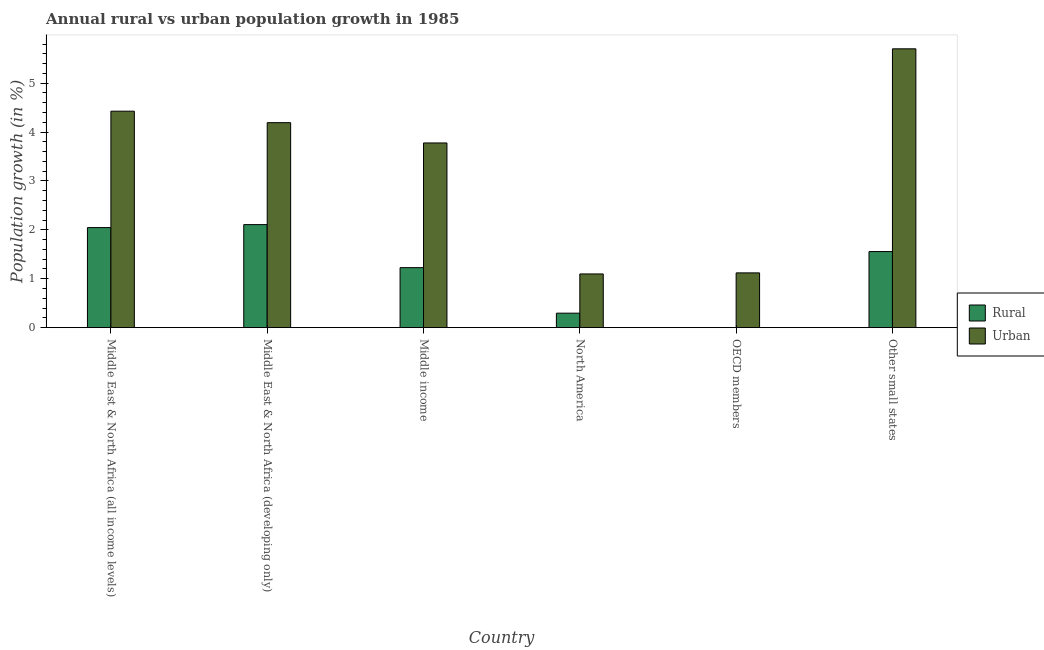What is the urban population growth in OECD members?
Your answer should be compact. 1.12. Across all countries, what is the maximum urban population growth?
Offer a very short reply. 5.7. Across all countries, what is the minimum urban population growth?
Provide a succinct answer. 1.1. In which country was the rural population growth maximum?
Make the answer very short. Middle East & North Africa (developing only). What is the total urban population growth in the graph?
Your answer should be compact. 20.32. What is the difference between the urban population growth in Middle income and that in North America?
Give a very brief answer. 2.68. What is the difference between the rural population growth in Middle East & North Africa (developing only) and the urban population growth in Middle East & North Africa (all income levels)?
Provide a short and direct response. -2.32. What is the average rural population growth per country?
Your answer should be very brief. 1.21. What is the difference between the urban population growth and rural population growth in Middle East & North Africa (all income levels)?
Offer a terse response. 2.38. In how many countries, is the rural population growth greater than 0.4 %?
Your answer should be compact. 4. What is the ratio of the rural population growth in Middle East & North Africa (developing only) to that in Other small states?
Provide a succinct answer. 1.35. Is the difference between the rural population growth in Middle East & North Africa (all income levels) and Middle East & North Africa (developing only) greater than the difference between the urban population growth in Middle East & North Africa (all income levels) and Middle East & North Africa (developing only)?
Your answer should be very brief. No. What is the difference between the highest and the second highest rural population growth?
Your response must be concise. 0.06. What is the difference between the highest and the lowest rural population growth?
Ensure brevity in your answer.  2.11. Are all the bars in the graph horizontal?
Offer a terse response. No. How many countries are there in the graph?
Give a very brief answer. 6. What is the difference between two consecutive major ticks on the Y-axis?
Provide a succinct answer. 1. Does the graph contain any zero values?
Your response must be concise. Yes. How many legend labels are there?
Your answer should be compact. 2. What is the title of the graph?
Keep it short and to the point. Annual rural vs urban population growth in 1985. What is the label or title of the Y-axis?
Make the answer very short. Population growth (in %). What is the Population growth (in %) in Rural in Middle East & North Africa (all income levels)?
Provide a short and direct response. 2.05. What is the Population growth (in %) of Urban  in Middle East & North Africa (all income levels)?
Provide a succinct answer. 4.43. What is the Population growth (in %) in Rural in Middle East & North Africa (developing only)?
Provide a succinct answer. 2.11. What is the Population growth (in %) in Urban  in Middle East & North Africa (developing only)?
Ensure brevity in your answer.  4.19. What is the Population growth (in %) in Rural in Middle income?
Provide a succinct answer. 1.23. What is the Population growth (in %) in Urban  in Middle income?
Offer a very short reply. 3.78. What is the Population growth (in %) of Rural in North America?
Your response must be concise. 0.3. What is the Population growth (in %) of Urban  in North America?
Your response must be concise. 1.1. What is the Population growth (in %) in Rural in OECD members?
Make the answer very short. 0. What is the Population growth (in %) in Urban  in OECD members?
Ensure brevity in your answer.  1.12. What is the Population growth (in %) of Rural in Other small states?
Your answer should be compact. 1.56. What is the Population growth (in %) in Urban  in Other small states?
Your answer should be compact. 5.7. Across all countries, what is the maximum Population growth (in %) in Rural?
Your answer should be very brief. 2.11. Across all countries, what is the maximum Population growth (in %) in Urban ?
Offer a very short reply. 5.7. Across all countries, what is the minimum Population growth (in %) in Urban ?
Your answer should be very brief. 1.1. What is the total Population growth (in %) of Rural in the graph?
Provide a short and direct response. 7.24. What is the total Population growth (in %) of Urban  in the graph?
Give a very brief answer. 20.32. What is the difference between the Population growth (in %) in Rural in Middle East & North Africa (all income levels) and that in Middle East & North Africa (developing only)?
Your response must be concise. -0.06. What is the difference between the Population growth (in %) in Urban  in Middle East & North Africa (all income levels) and that in Middle East & North Africa (developing only)?
Offer a very short reply. 0.23. What is the difference between the Population growth (in %) in Rural in Middle East & North Africa (all income levels) and that in Middle income?
Give a very brief answer. 0.82. What is the difference between the Population growth (in %) in Urban  in Middle East & North Africa (all income levels) and that in Middle income?
Provide a succinct answer. 0.65. What is the difference between the Population growth (in %) of Rural in Middle East & North Africa (all income levels) and that in North America?
Give a very brief answer. 1.75. What is the difference between the Population growth (in %) of Urban  in Middle East & North Africa (all income levels) and that in North America?
Your response must be concise. 3.33. What is the difference between the Population growth (in %) of Urban  in Middle East & North Africa (all income levels) and that in OECD members?
Ensure brevity in your answer.  3.31. What is the difference between the Population growth (in %) of Rural in Middle East & North Africa (all income levels) and that in Other small states?
Make the answer very short. 0.49. What is the difference between the Population growth (in %) of Urban  in Middle East & North Africa (all income levels) and that in Other small states?
Make the answer very short. -1.28. What is the difference between the Population growth (in %) of Rural in Middle East & North Africa (developing only) and that in Middle income?
Keep it short and to the point. 0.88. What is the difference between the Population growth (in %) of Urban  in Middle East & North Africa (developing only) and that in Middle income?
Provide a succinct answer. 0.41. What is the difference between the Population growth (in %) in Rural in Middle East & North Africa (developing only) and that in North America?
Make the answer very short. 1.81. What is the difference between the Population growth (in %) in Urban  in Middle East & North Africa (developing only) and that in North America?
Offer a terse response. 3.09. What is the difference between the Population growth (in %) of Urban  in Middle East & North Africa (developing only) and that in OECD members?
Keep it short and to the point. 3.07. What is the difference between the Population growth (in %) in Rural in Middle East & North Africa (developing only) and that in Other small states?
Give a very brief answer. 0.55. What is the difference between the Population growth (in %) of Urban  in Middle East & North Africa (developing only) and that in Other small states?
Your answer should be compact. -1.51. What is the difference between the Population growth (in %) of Rural in Middle income and that in North America?
Keep it short and to the point. 0.93. What is the difference between the Population growth (in %) in Urban  in Middle income and that in North America?
Your response must be concise. 2.68. What is the difference between the Population growth (in %) of Urban  in Middle income and that in OECD members?
Ensure brevity in your answer.  2.66. What is the difference between the Population growth (in %) in Rural in Middle income and that in Other small states?
Keep it short and to the point. -0.33. What is the difference between the Population growth (in %) in Urban  in Middle income and that in Other small states?
Your answer should be very brief. -1.93. What is the difference between the Population growth (in %) of Urban  in North America and that in OECD members?
Ensure brevity in your answer.  -0.02. What is the difference between the Population growth (in %) of Rural in North America and that in Other small states?
Ensure brevity in your answer.  -1.26. What is the difference between the Population growth (in %) in Urban  in North America and that in Other small states?
Your response must be concise. -4.6. What is the difference between the Population growth (in %) of Urban  in OECD members and that in Other small states?
Your answer should be compact. -4.58. What is the difference between the Population growth (in %) of Rural in Middle East & North Africa (all income levels) and the Population growth (in %) of Urban  in Middle East & North Africa (developing only)?
Make the answer very short. -2.15. What is the difference between the Population growth (in %) in Rural in Middle East & North Africa (all income levels) and the Population growth (in %) in Urban  in Middle income?
Ensure brevity in your answer.  -1.73. What is the difference between the Population growth (in %) in Rural in Middle East & North Africa (all income levels) and the Population growth (in %) in Urban  in North America?
Offer a terse response. 0.95. What is the difference between the Population growth (in %) in Rural in Middle East & North Africa (all income levels) and the Population growth (in %) in Urban  in OECD members?
Ensure brevity in your answer.  0.93. What is the difference between the Population growth (in %) of Rural in Middle East & North Africa (all income levels) and the Population growth (in %) of Urban  in Other small states?
Provide a succinct answer. -3.66. What is the difference between the Population growth (in %) in Rural in Middle East & North Africa (developing only) and the Population growth (in %) in Urban  in Middle income?
Make the answer very short. -1.67. What is the difference between the Population growth (in %) in Rural in Middle East & North Africa (developing only) and the Population growth (in %) in Urban  in North America?
Offer a very short reply. 1.01. What is the difference between the Population growth (in %) of Rural in Middle East & North Africa (developing only) and the Population growth (in %) of Urban  in Other small states?
Provide a succinct answer. -3.6. What is the difference between the Population growth (in %) of Rural in Middle income and the Population growth (in %) of Urban  in North America?
Your response must be concise. 0.13. What is the difference between the Population growth (in %) in Rural in Middle income and the Population growth (in %) in Urban  in OECD members?
Offer a very short reply. 0.11. What is the difference between the Population growth (in %) in Rural in Middle income and the Population growth (in %) in Urban  in Other small states?
Keep it short and to the point. -4.48. What is the difference between the Population growth (in %) in Rural in North America and the Population growth (in %) in Urban  in OECD members?
Keep it short and to the point. -0.82. What is the difference between the Population growth (in %) in Rural in North America and the Population growth (in %) in Urban  in Other small states?
Provide a succinct answer. -5.41. What is the average Population growth (in %) of Rural per country?
Your answer should be very brief. 1.21. What is the average Population growth (in %) in Urban  per country?
Your response must be concise. 3.39. What is the difference between the Population growth (in %) in Rural and Population growth (in %) in Urban  in Middle East & North Africa (all income levels)?
Offer a terse response. -2.38. What is the difference between the Population growth (in %) in Rural and Population growth (in %) in Urban  in Middle East & North Africa (developing only)?
Your response must be concise. -2.09. What is the difference between the Population growth (in %) of Rural and Population growth (in %) of Urban  in Middle income?
Your response must be concise. -2.55. What is the difference between the Population growth (in %) of Rural and Population growth (in %) of Urban  in North America?
Provide a succinct answer. -0.8. What is the difference between the Population growth (in %) in Rural and Population growth (in %) in Urban  in Other small states?
Provide a short and direct response. -4.15. What is the ratio of the Population growth (in %) of Rural in Middle East & North Africa (all income levels) to that in Middle East & North Africa (developing only)?
Keep it short and to the point. 0.97. What is the ratio of the Population growth (in %) in Urban  in Middle East & North Africa (all income levels) to that in Middle East & North Africa (developing only)?
Your response must be concise. 1.06. What is the ratio of the Population growth (in %) in Rural in Middle East & North Africa (all income levels) to that in Middle income?
Your answer should be very brief. 1.67. What is the ratio of the Population growth (in %) in Urban  in Middle East & North Africa (all income levels) to that in Middle income?
Offer a very short reply. 1.17. What is the ratio of the Population growth (in %) in Rural in Middle East & North Africa (all income levels) to that in North America?
Keep it short and to the point. 6.9. What is the ratio of the Population growth (in %) in Urban  in Middle East & North Africa (all income levels) to that in North America?
Give a very brief answer. 4.03. What is the ratio of the Population growth (in %) in Urban  in Middle East & North Africa (all income levels) to that in OECD members?
Offer a terse response. 3.95. What is the ratio of the Population growth (in %) in Rural in Middle East & North Africa (all income levels) to that in Other small states?
Offer a very short reply. 1.32. What is the ratio of the Population growth (in %) of Urban  in Middle East & North Africa (all income levels) to that in Other small states?
Your answer should be compact. 0.78. What is the ratio of the Population growth (in %) in Rural in Middle East & North Africa (developing only) to that in Middle income?
Provide a short and direct response. 1.72. What is the ratio of the Population growth (in %) in Urban  in Middle East & North Africa (developing only) to that in Middle income?
Offer a terse response. 1.11. What is the ratio of the Population growth (in %) in Rural in Middle East & North Africa (developing only) to that in North America?
Your answer should be very brief. 7.11. What is the ratio of the Population growth (in %) in Urban  in Middle East & North Africa (developing only) to that in North America?
Offer a very short reply. 3.82. What is the ratio of the Population growth (in %) of Urban  in Middle East & North Africa (developing only) to that in OECD members?
Provide a succinct answer. 3.74. What is the ratio of the Population growth (in %) in Rural in Middle East & North Africa (developing only) to that in Other small states?
Your answer should be very brief. 1.35. What is the ratio of the Population growth (in %) in Urban  in Middle East & North Africa (developing only) to that in Other small states?
Give a very brief answer. 0.74. What is the ratio of the Population growth (in %) in Rural in Middle income to that in North America?
Provide a succinct answer. 4.14. What is the ratio of the Population growth (in %) in Urban  in Middle income to that in North America?
Your response must be concise. 3.44. What is the ratio of the Population growth (in %) of Urban  in Middle income to that in OECD members?
Provide a short and direct response. 3.37. What is the ratio of the Population growth (in %) in Rural in Middle income to that in Other small states?
Give a very brief answer. 0.79. What is the ratio of the Population growth (in %) of Urban  in Middle income to that in Other small states?
Ensure brevity in your answer.  0.66. What is the ratio of the Population growth (in %) of Urban  in North America to that in OECD members?
Provide a short and direct response. 0.98. What is the ratio of the Population growth (in %) in Rural in North America to that in Other small states?
Your answer should be very brief. 0.19. What is the ratio of the Population growth (in %) of Urban  in North America to that in Other small states?
Your response must be concise. 0.19. What is the ratio of the Population growth (in %) of Urban  in OECD members to that in Other small states?
Ensure brevity in your answer.  0.2. What is the difference between the highest and the second highest Population growth (in %) in Rural?
Offer a very short reply. 0.06. What is the difference between the highest and the second highest Population growth (in %) in Urban ?
Your response must be concise. 1.28. What is the difference between the highest and the lowest Population growth (in %) of Rural?
Your answer should be compact. 2.11. What is the difference between the highest and the lowest Population growth (in %) in Urban ?
Give a very brief answer. 4.6. 